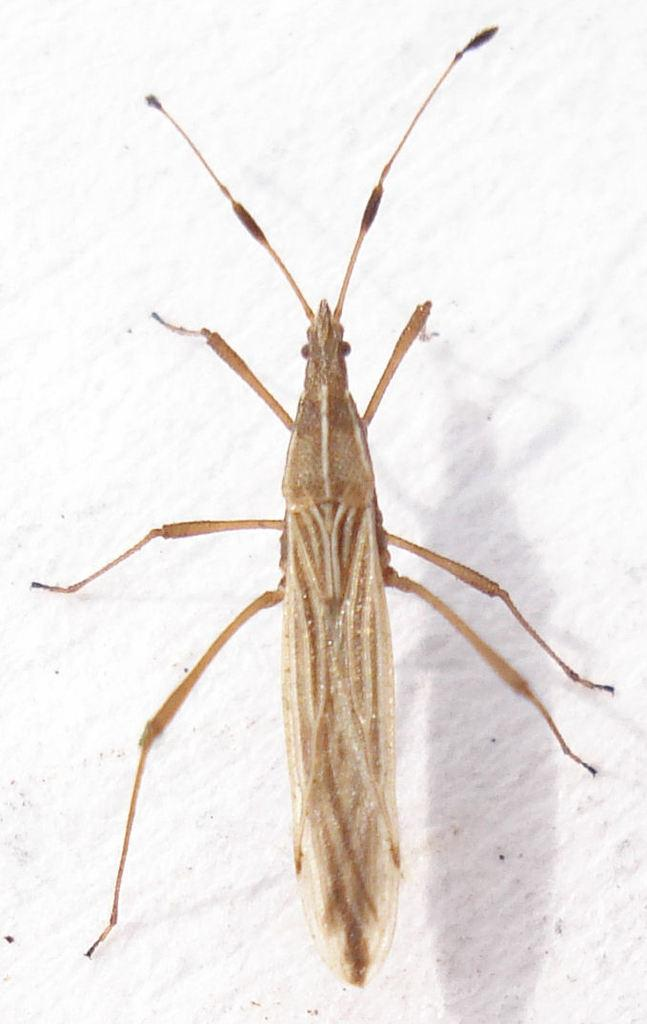What type of creature can be seen in the image? There is an insect in the image. Where is the insect located? The insect is on the ground. What type of circle can be seen on the calendar in the image? There is no circle or calendar present in the image; it only features an insect on the ground. 